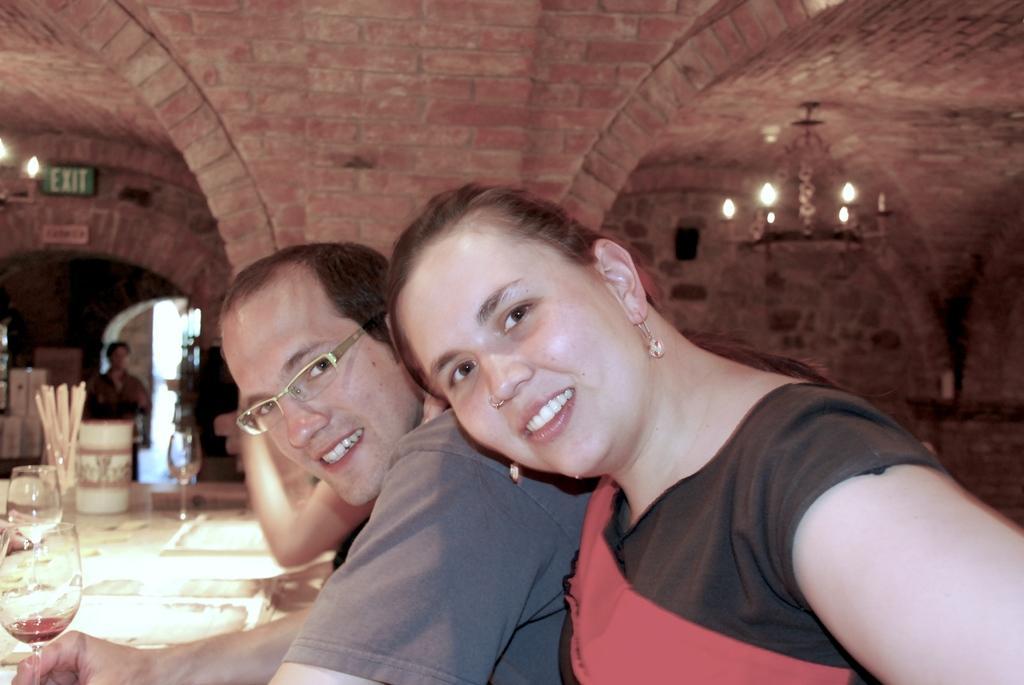Describe this image in one or two sentences. In the center of the image there are two people. At the left there is a table and there are glasses, mugs which are placed on the table. In the background there is a brick wall. At the top there is a chandelier. 